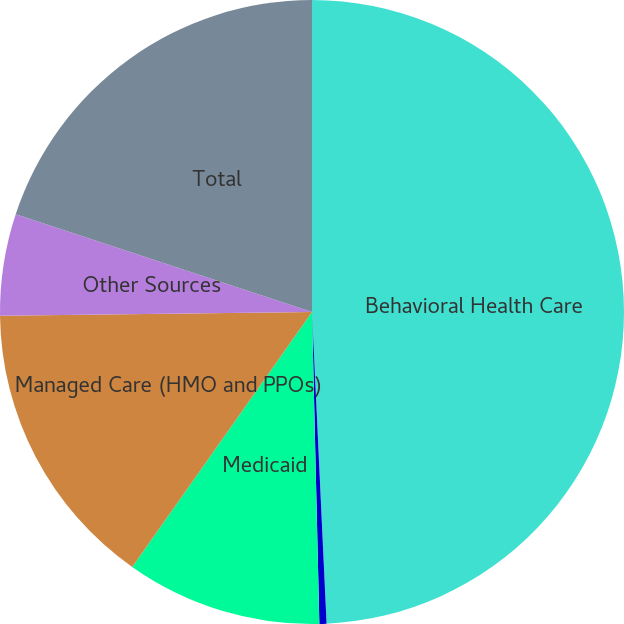Convert chart to OTSL. <chart><loc_0><loc_0><loc_500><loc_500><pie_chart><fcel>Behavioral Health Care<fcel>Medicare<fcel>Medicaid<fcel>Managed Care (HMO and PPOs)<fcel>Other Sources<fcel>Total<nl><fcel>49.26%<fcel>0.37%<fcel>10.15%<fcel>15.04%<fcel>5.26%<fcel>19.93%<nl></chart> 